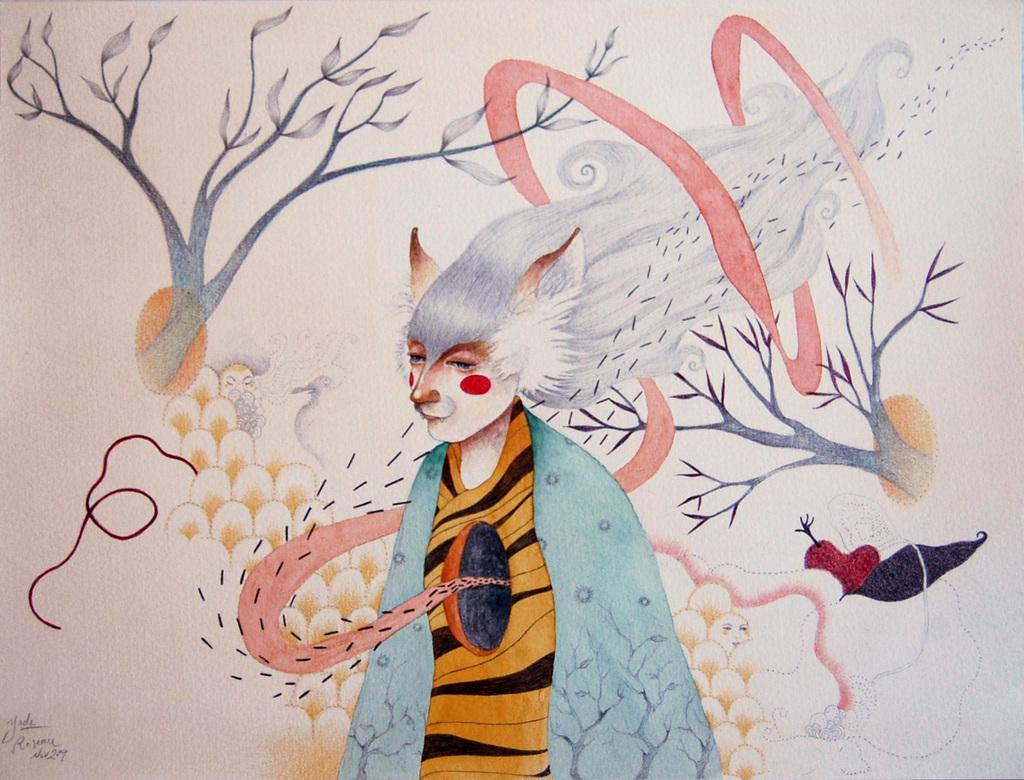What type of natural elements can be seen in the image? There are branches and leaves in the image. Are there any man-made objects visible in the image? Yes, there are some objects in the image. Is there any indication of the image's source or ownership? Yes, there is a watermark in the image. What type of animation is present in the image? There is an animated image of a person in the image. What type of meal is being prepared on the dock in the image? There is no dock or meal preparation present in the image. 